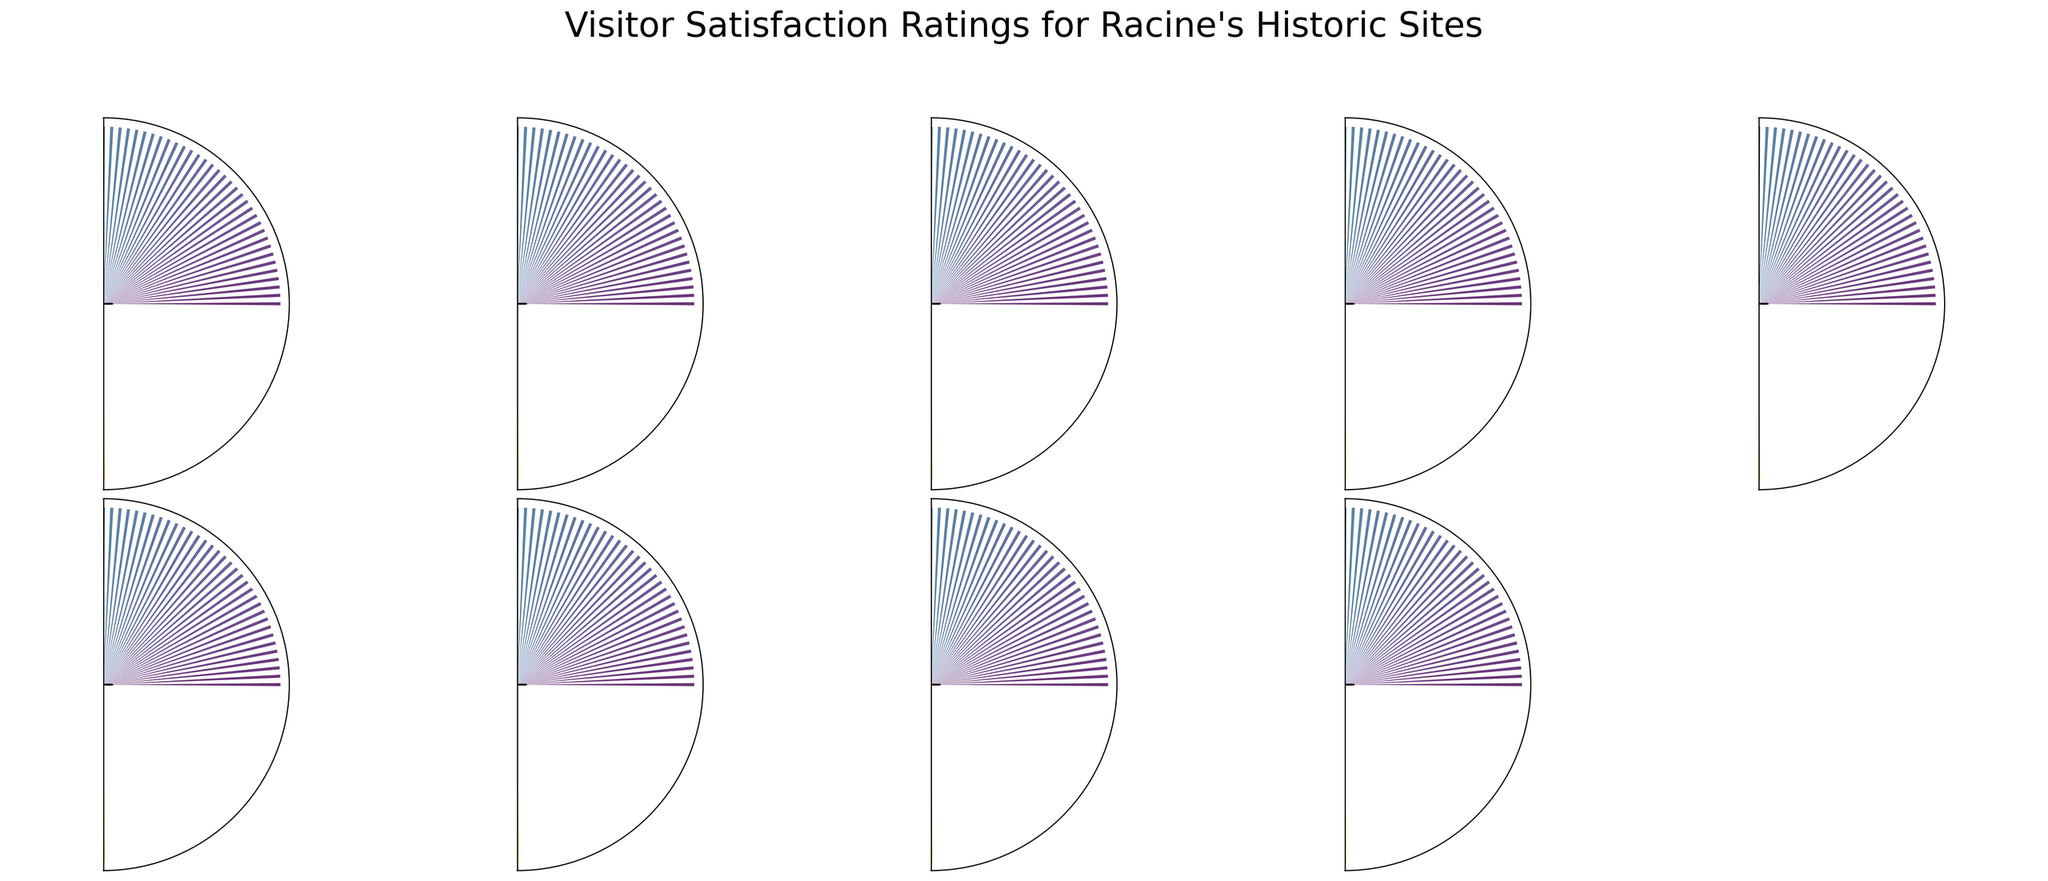What's the highest visitor satisfaction rating recorded in the figure? Look for the gauge chart with the highest rating number displayed. SC Johnson Headquarters has a rating of 95.
Answer: 95 Which historic site has the lowest visitor satisfaction rating? Identify the site with the smallest number on its gauge. Racine County Courthouse has a rating of 83.
Answer: Racine County Courthouse What is the average visitor satisfaction rating for the historic sites shown? Add all the satisfaction ratings and divide by the number of sites: (92+87+85+95+83+88+90+94+86+89)/10 = 88.9.
Answer: 88.9 How many historic sites have a satisfaction rating above 90? Count the gauges with ratings greater than 90. SC Johnson Headquarters, Wind Point Lighthouse, Wingspread, and Racine Art Museum have ratings above 90.
Answer: 4 What is the difference in visitor satisfaction rating between Racine Zoo and Racine Art Museum? Subtract the Racine Zoo rating from Racine Art Museum rating. 90 - 85 = 5.
Answer: 5 Which two historic sites have the closest visitor satisfaction ratings? Identify two sites with ratings that are numerically closest. Racine Heritage Museum (87) and Racine Theatre Guild (86) have the closest ratings.
Answer: Racine Heritage Museum and Racine Theatre Guild What's the median visitor satisfaction rating amongst the historic sites? Arrange the ratings in numerical order and identify the middle value. The ordered ratings are 83, 85, 86, 87, 88, 89, 90, 92, 94, 95. The middle values (88 and 89) are averaged to get the median. (88 + 89) / 2 = 88.5.
Answer: 88.5 Which historic site has a satisfaction rating closest to 88? Find the rating nearest to 88. Reefpoint Marina is the historic site with the closest satisfaction rating of 88.
Answer: Reefpoint Marina 